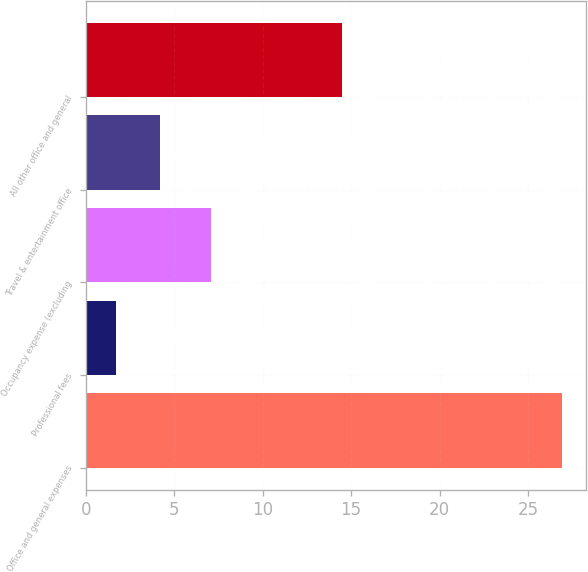Convert chart to OTSL. <chart><loc_0><loc_0><loc_500><loc_500><bar_chart><fcel>Office and general expenses<fcel>Professional fees<fcel>Occupancy expense (excluding<fcel>Travel & entertainment office<fcel>All other office and general<nl><fcel>26.9<fcel>1.7<fcel>7.1<fcel>4.22<fcel>14.5<nl></chart> 